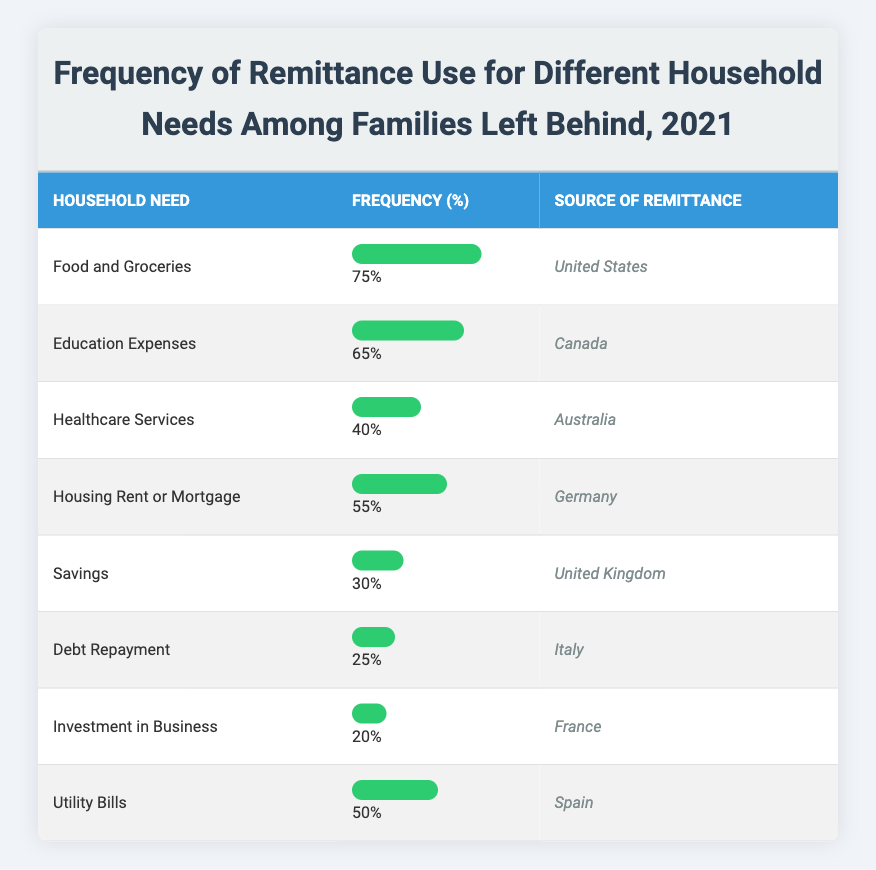What is the frequency percentage for Food and Groceries? The table shows that Food and Groceries has a frequency percentage of 75%.
Answer: 75% Which source of remittance is used most for Education Expenses? According to the table, the source of remittance most used for Education Expenses is Canada with a frequency percentage of 65%.
Answer: Canada How many household needs have a frequency percentage above 50%? By examining the table, the household needs with frequency percentages above 50% are Food and Groceries (75%), Education Expenses (65%), Housing Rent or Mortgage (55%), and Utility Bills (50%). This totals four household needs.
Answer: 4 Is it true that Debt Repayment has a higher frequency percentage than Savings? The frequency percentage for Debt Repayment is 25% and for Savings, it is 30%. Since 25% is not higher than 30%, the statement is false.
Answer: No What is the average frequency percentage of all the household needs listed? The frequency percentages are 75, 65, 40, 55, 30, 25, 20, and 50. Adding these gives 75 + 65 + 40 + 55 + 30 + 25 + 20 + 50 = 360. There are 8 values, so the average is 360/8 = 45.
Answer: 45 Which remittance source is associated with the lowest frequency percentage for household needs? The table indicates that the source of remittance associated with the lowest frequency percentage is France, as it has a frequency percentage of 20% for Investment in Business.
Answer: France What percentage of households use remittances for Utility Bills? The table specifies that 50% of households use remittances for Utility Bills.
Answer: 50% Compare the frequency percentages for Healthcare Services and Investment in Business. Which one is higher? Healthcare Services has a frequency percentage of 40%, while Investment in Business has a frequency percentage of 20%. Therefore, Healthcare Services is higher.
Answer: Healthcare Services is higher 